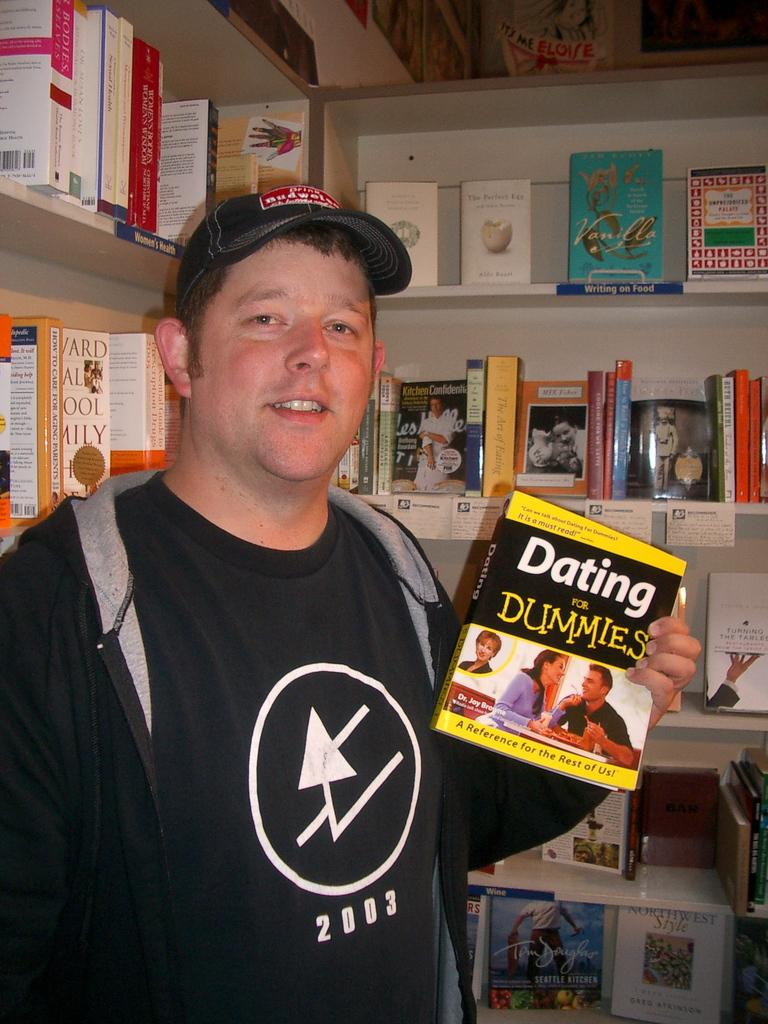Provide a one-sentence caption for the provided image. A man holding the book Dating for Dummies in a bookstore. 